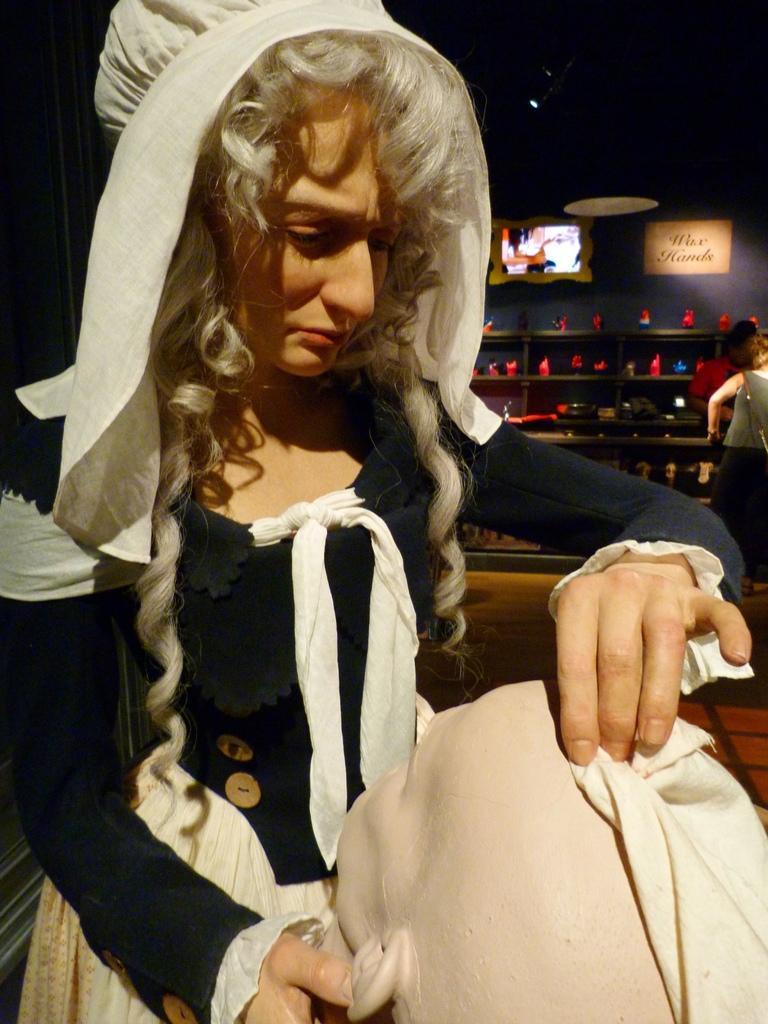How would you summarize this image in a sentence or two? In this image we can see a lady and an object. In the background of the image there are shelves, name boards, persons, wall and other objects. On the left side of the image there is a black object. 